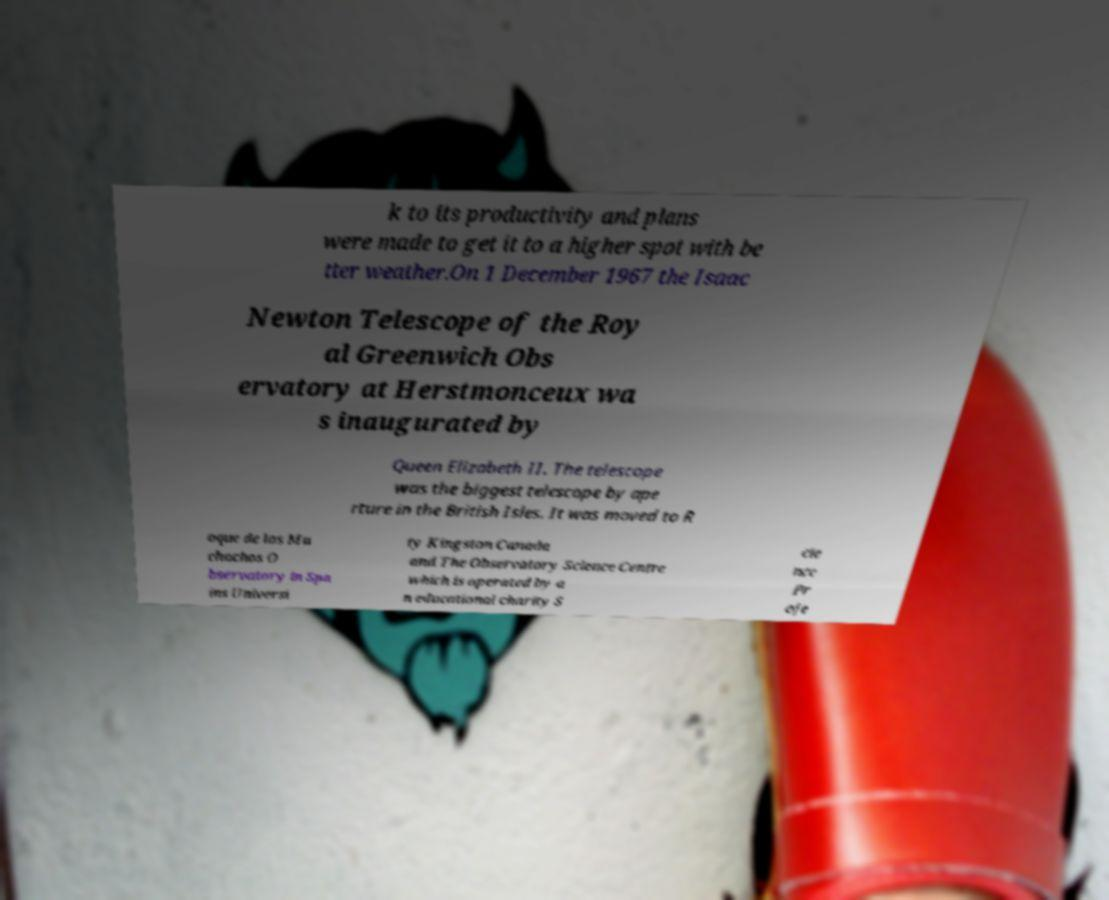What messages or text are displayed in this image? I need them in a readable, typed format. k to its productivity and plans were made to get it to a higher spot with be tter weather.On 1 December 1967 the Isaac Newton Telescope of the Roy al Greenwich Obs ervatory at Herstmonceux wa s inaugurated by Queen Elizabeth II. The telescope was the biggest telescope by ape rture in the British Isles. It was moved to R oque de los Mu chachos O bservatory in Spa ins Universi ty Kingston Canada and The Observatory Science Centre which is operated by a n educational charity S cie nce Pr oje 